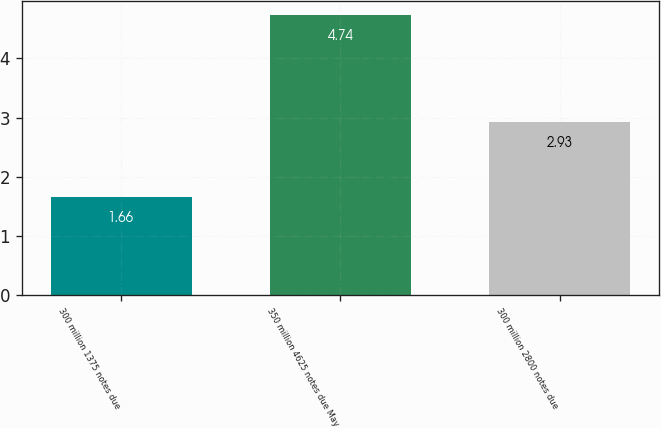Convert chart to OTSL. <chart><loc_0><loc_0><loc_500><loc_500><bar_chart><fcel>300 million 1375 notes due<fcel>350 million 4625 notes due May<fcel>300 million 2800 notes due<nl><fcel>1.66<fcel>4.74<fcel>2.93<nl></chart> 